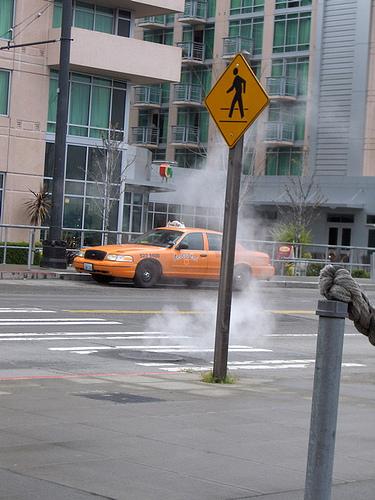What type of car is this?
Write a very short answer. Taxi. What kind of sign is on the sidewalk?
Be succinct. Pedestrian crossing. What is the building made of?
Answer briefly. Concrete. What color is the car?
Write a very short answer. Orange. Can pedestrians cross safely?
Write a very short answer. Yes. What color is the sign?
Be succinct. Yellow. What is the store in the background?
Give a very brief answer. Apartment. 